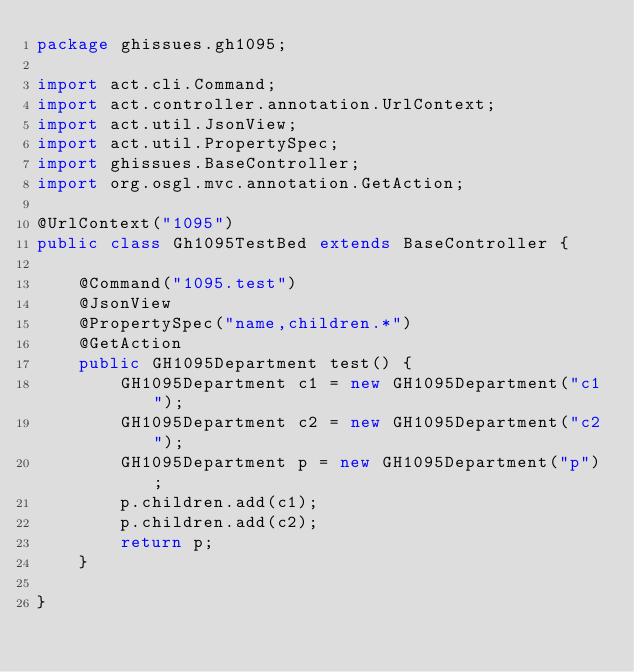<code> <loc_0><loc_0><loc_500><loc_500><_Java_>package ghissues.gh1095;

import act.cli.Command;
import act.controller.annotation.UrlContext;
import act.util.JsonView;
import act.util.PropertySpec;
import ghissues.BaseController;
import org.osgl.mvc.annotation.GetAction;

@UrlContext("1095")
public class Gh1095TestBed extends BaseController {

    @Command("1095.test")
    @JsonView
    @PropertySpec("name,children.*")
    @GetAction
    public GH1095Department test() {
        GH1095Department c1 = new GH1095Department("c1");
        GH1095Department c2 = new GH1095Department("c2");
        GH1095Department p = new GH1095Department("p");
        p.children.add(c1);
        p.children.add(c2);
        return p;
    }

}
</code> 